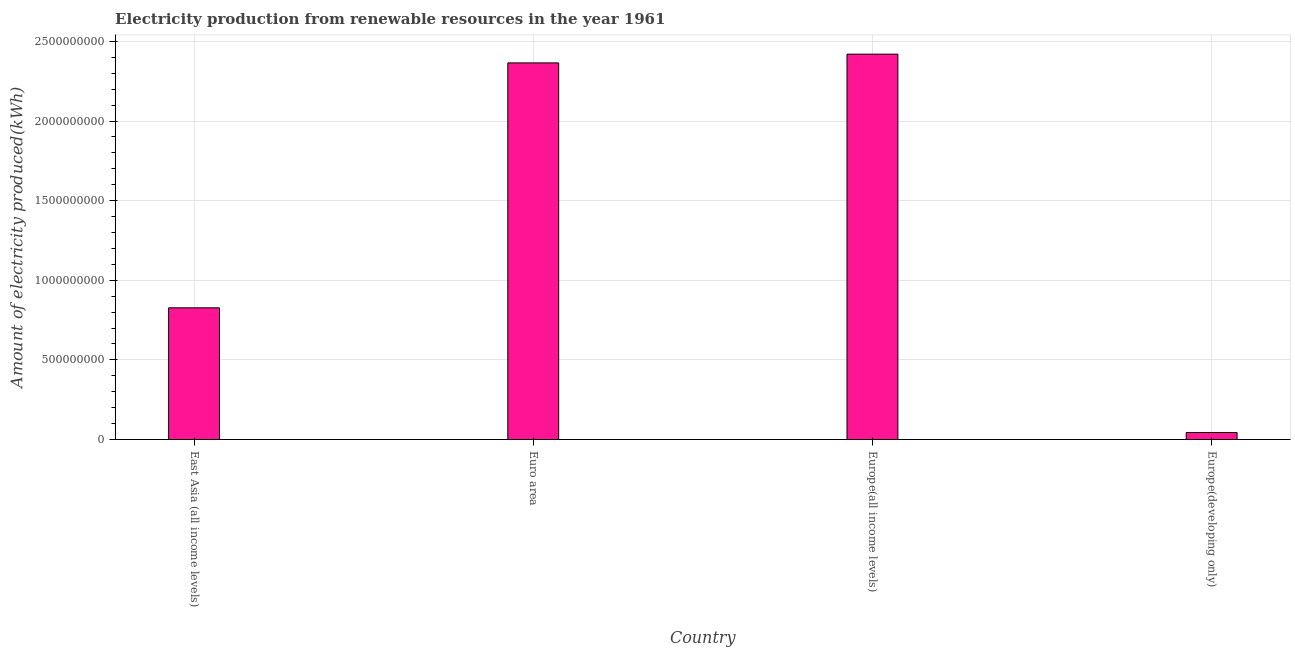Does the graph contain grids?
Offer a very short reply. Yes. What is the title of the graph?
Provide a succinct answer. Electricity production from renewable resources in the year 1961. What is the label or title of the Y-axis?
Your answer should be compact. Amount of electricity produced(kWh). What is the amount of electricity produced in Europe(all income levels)?
Your answer should be very brief. 2.42e+09. Across all countries, what is the maximum amount of electricity produced?
Ensure brevity in your answer.  2.42e+09. Across all countries, what is the minimum amount of electricity produced?
Ensure brevity in your answer.  4.40e+07. In which country was the amount of electricity produced maximum?
Offer a terse response. Europe(all income levels). In which country was the amount of electricity produced minimum?
Keep it short and to the point. Europe(developing only). What is the sum of the amount of electricity produced?
Offer a very short reply. 5.66e+09. What is the difference between the amount of electricity produced in Euro area and Europe(developing only)?
Give a very brief answer. 2.32e+09. What is the average amount of electricity produced per country?
Your answer should be very brief. 1.41e+09. What is the median amount of electricity produced?
Keep it short and to the point. 1.60e+09. In how many countries, is the amount of electricity produced greater than 200000000 kWh?
Ensure brevity in your answer.  3. What is the ratio of the amount of electricity produced in Euro area to that in Europe(developing only)?
Keep it short and to the point. 53.75. Is the difference between the amount of electricity produced in Euro area and Europe(all income levels) greater than the difference between any two countries?
Give a very brief answer. No. What is the difference between the highest and the second highest amount of electricity produced?
Your answer should be very brief. 5.50e+07. What is the difference between the highest and the lowest amount of electricity produced?
Your response must be concise. 2.38e+09. In how many countries, is the amount of electricity produced greater than the average amount of electricity produced taken over all countries?
Make the answer very short. 2. Are all the bars in the graph horizontal?
Your response must be concise. No. What is the Amount of electricity produced(kWh) of East Asia (all income levels)?
Give a very brief answer. 8.27e+08. What is the Amount of electricity produced(kWh) in Euro area?
Provide a succinct answer. 2.36e+09. What is the Amount of electricity produced(kWh) in Europe(all income levels)?
Offer a terse response. 2.42e+09. What is the Amount of electricity produced(kWh) in Europe(developing only)?
Provide a short and direct response. 4.40e+07. What is the difference between the Amount of electricity produced(kWh) in East Asia (all income levels) and Euro area?
Ensure brevity in your answer.  -1.54e+09. What is the difference between the Amount of electricity produced(kWh) in East Asia (all income levels) and Europe(all income levels)?
Offer a very short reply. -1.59e+09. What is the difference between the Amount of electricity produced(kWh) in East Asia (all income levels) and Europe(developing only)?
Your answer should be compact. 7.83e+08. What is the difference between the Amount of electricity produced(kWh) in Euro area and Europe(all income levels)?
Provide a short and direct response. -5.50e+07. What is the difference between the Amount of electricity produced(kWh) in Euro area and Europe(developing only)?
Make the answer very short. 2.32e+09. What is the difference between the Amount of electricity produced(kWh) in Europe(all income levels) and Europe(developing only)?
Ensure brevity in your answer.  2.38e+09. What is the ratio of the Amount of electricity produced(kWh) in East Asia (all income levels) to that in Euro area?
Give a very brief answer. 0.35. What is the ratio of the Amount of electricity produced(kWh) in East Asia (all income levels) to that in Europe(all income levels)?
Your response must be concise. 0.34. What is the ratio of the Amount of electricity produced(kWh) in East Asia (all income levels) to that in Europe(developing only)?
Keep it short and to the point. 18.8. What is the ratio of the Amount of electricity produced(kWh) in Euro area to that in Europe(developing only)?
Offer a very short reply. 53.75. What is the ratio of the Amount of electricity produced(kWh) in Europe(all income levels) to that in Europe(developing only)?
Keep it short and to the point. 55. 